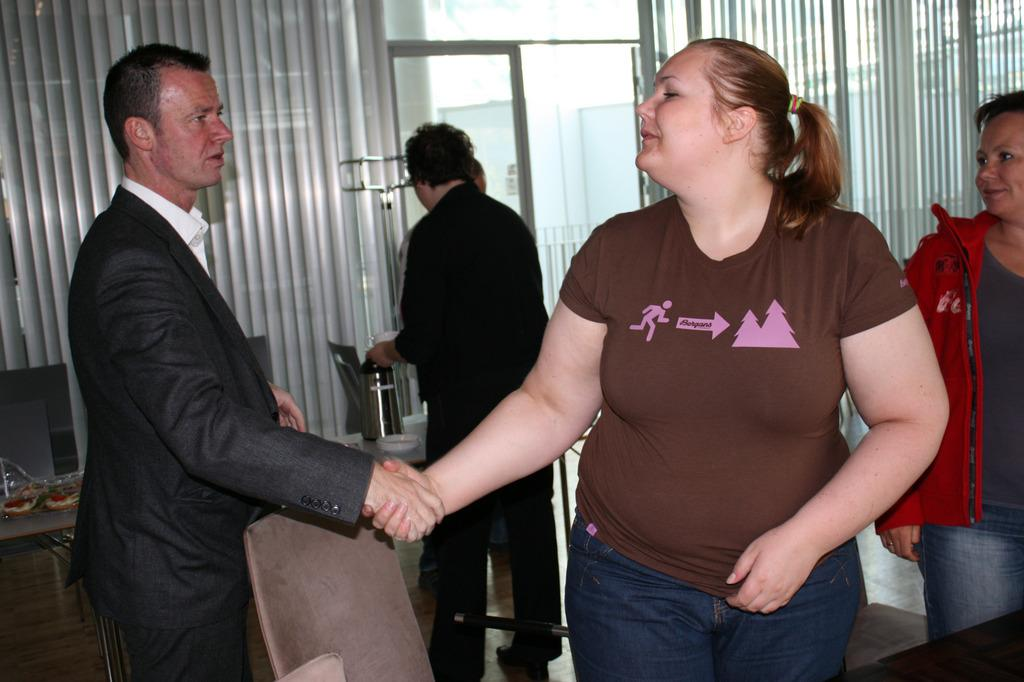How many people are in the image? There are persons in the image. What are two of the persons doing in the image? Two persons are shaking hands in the front. What can be seen in the middle of the image? There are window blinds in the middle of the image. What type of square is visible on the hand of one of the persons in the image? There is no square visible on the hand of any person in the image. What is the texture of the handshake between the two persons in the image? The texture of the handshake cannot be determined from the image. 